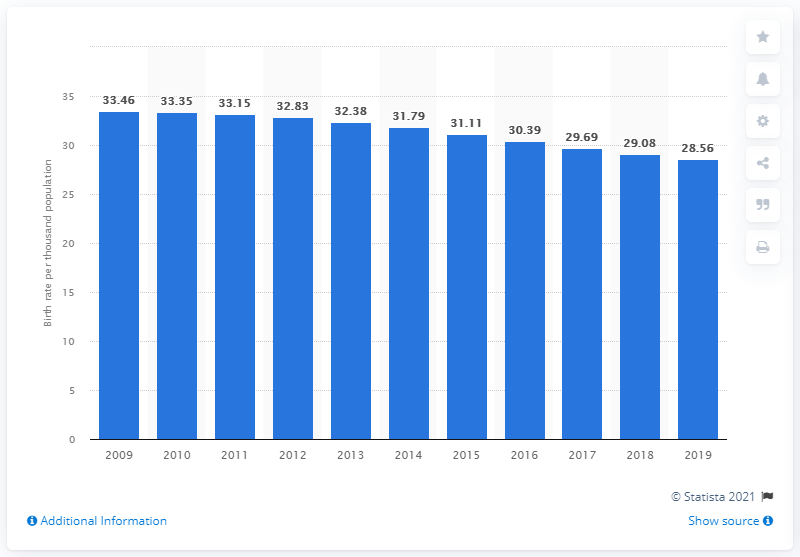Specify some key components in this picture. In 2019, the crude birth rate in Iraq was 28.56. 